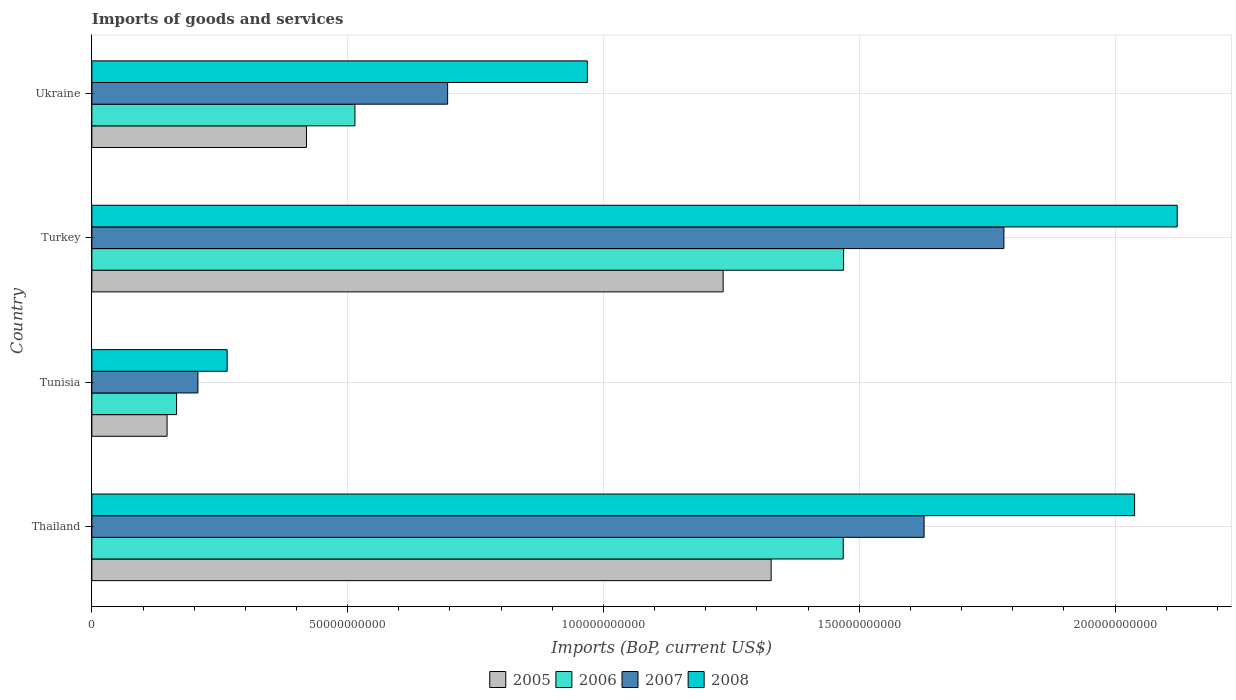Are the number of bars per tick equal to the number of legend labels?
Your answer should be very brief. Yes. What is the label of the 3rd group of bars from the top?
Make the answer very short. Tunisia. What is the amount spent on imports in 2008 in Turkey?
Offer a terse response. 2.12e+11. Across all countries, what is the maximum amount spent on imports in 2007?
Your answer should be compact. 1.78e+11. Across all countries, what is the minimum amount spent on imports in 2005?
Keep it short and to the point. 1.47e+1. In which country was the amount spent on imports in 2006 maximum?
Provide a short and direct response. Turkey. In which country was the amount spent on imports in 2005 minimum?
Provide a succinct answer. Tunisia. What is the total amount spent on imports in 2008 in the graph?
Offer a very short reply. 5.39e+11. What is the difference between the amount spent on imports in 2006 in Tunisia and that in Ukraine?
Ensure brevity in your answer.  -3.49e+1. What is the difference between the amount spent on imports in 2006 in Turkey and the amount spent on imports in 2005 in Ukraine?
Provide a short and direct response. 1.05e+11. What is the average amount spent on imports in 2007 per country?
Ensure brevity in your answer.  1.08e+11. What is the difference between the amount spent on imports in 2008 and amount spent on imports in 2007 in Thailand?
Make the answer very short. 4.11e+1. What is the ratio of the amount spent on imports in 2007 in Thailand to that in Ukraine?
Provide a succinct answer. 2.34. Is the difference between the amount spent on imports in 2008 in Thailand and Ukraine greater than the difference between the amount spent on imports in 2007 in Thailand and Ukraine?
Make the answer very short. Yes. What is the difference between the highest and the second highest amount spent on imports in 2008?
Offer a terse response. 8.33e+09. What is the difference between the highest and the lowest amount spent on imports in 2006?
Give a very brief answer. 1.30e+11. In how many countries, is the amount spent on imports in 2006 greater than the average amount spent on imports in 2006 taken over all countries?
Offer a very short reply. 2. Is the sum of the amount spent on imports in 2007 in Turkey and Ukraine greater than the maximum amount spent on imports in 2006 across all countries?
Provide a succinct answer. Yes. Is it the case that in every country, the sum of the amount spent on imports in 2008 and amount spent on imports in 2006 is greater than the amount spent on imports in 2005?
Keep it short and to the point. Yes. Are all the bars in the graph horizontal?
Make the answer very short. Yes. What is the difference between two consecutive major ticks on the X-axis?
Your answer should be compact. 5.00e+1. Are the values on the major ticks of X-axis written in scientific E-notation?
Keep it short and to the point. No. Does the graph contain grids?
Make the answer very short. Yes. What is the title of the graph?
Your answer should be compact. Imports of goods and services. What is the label or title of the X-axis?
Your answer should be very brief. Imports (BoP, current US$). What is the label or title of the Y-axis?
Ensure brevity in your answer.  Country. What is the Imports (BoP, current US$) in 2005 in Thailand?
Provide a short and direct response. 1.33e+11. What is the Imports (BoP, current US$) in 2006 in Thailand?
Your response must be concise. 1.47e+11. What is the Imports (BoP, current US$) in 2007 in Thailand?
Provide a succinct answer. 1.63e+11. What is the Imports (BoP, current US$) of 2008 in Thailand?
Offer a terse response. 2.04e+11. What is the Imports (BoP, current US$) of 2005 in Tunisia?
Your answer should be very brief. 1.47e+1. What is the Imports (BoP, current US$) in 2006 in Tunisia?
Offer a terse response. 1.66e+1. What is the Imports (BoP, current US$) of 2007 in Tunisia?
Offer a very short reply. 2.07e+1. What is the Imports (BoP, current US$) of 2008 in Tunisia?
Your answer should be compact. 2.64e+1. What is the Imports (BoP, current US$) of 2005 in Turkey?
Offer a terse response. 1.23e+11. What is the Imports (BoP, current US$) of 2006 in Turkey?
Your answer should be compact. 1.47e+11. What is the Imports (BoP, current US$) in 2007 in Turkey?
Keep it short and to the point. 1.78e+11. What is the Imports (BoP, current US$) in 2008 in Turkey?
Make the answer very short. 2.12e+11. What is the Imports (BoP, current US$) in 2005 in Ukraine?
Keep it short and to the point. 4.20e+1. What is the Imports (BoP, current US$) in 2006 in Ukraine?
Provide a succinct answer. 5.14e+1. What is the Imports (BoP, current US$) of 2007 in Ukraine?
Offer a very short reply. 6.95e+1. What is the Imports (BoP, current US$) of 2008 in Ukraine?
Give a very brief answer. 9.68e+1. Across all countries, what is the maximum Imports (BoP, current US$) in 2005?
Your answer should be compact. 1.33e+11. Across all countries, what is the maximum Imports (BoP, current US$) in 2006?
Offer a terse response. 1.47e+11. Across all countries, what is the maximum Imports (BoP, current US$) in 2007?
Your answer should be very brief. 1.78e+11. Across all countries, what is the maximum Imports (BoP, current US$) in 2008?
Your answer should be very brief. 2.12e+11. Across all countries, what is the minimum Imports (BoP, current US$) of 2005?
Provide a short and direct response. 1.47e+1. Across all countries, what is the minimum Imports (BoP, current US$) of 2006?
Your answer should be compact. 1.66e+1. Across all countries, what is the minimum Imports (BoP, current US$) of 2007?
Your answer should be very brief. 2.07e+1. Across all countries, what is the minimum Imports (BoP, current US$) of 2008?
Give a very brief answer. 2.64e+1. What is the total Imports (BoP, current US$) in 2005 in the graph?
Provide a succinct answer. 3.13e+11. What is the total Imports (BoP, current US$) of 2006 in the graph?
Your answer should be compact. 3.62e+11. What is the total Imports (BoP, current US$) in 2007 in the graph?
Provide a succinct answer. 4.31e+11. What is the total Imports (BoP, current US$) in 2008 in the graph?
Offer a very short reply. 5.39e+11. What is the difference between the Imports (BoP, current US$) of 2005 in Thailand and that in Tunisia?
Provide a succinct answer. 1.18e+11. What is the difference between the Imports (BoP, current US$) in 2006 in Thailand and that in Tunisia?
Provide a short and direct response. 1.30e+11. What is the difference between the Imports (BoP, current US$) in 2007 in Thailand and that in Tunisia?
Offer a terse response. 1.42e+11. What is the difference between the Imports (BoP, current US$) of 2008 in Thailand and that in Tunisia?
Your answer should be compact. 1.77e+11. What is the difference between the Imports (BoP, current US$) in 2005 in Thailand and that in Turkey?
Your answer should be compact. 9.38e+09. What is the difference between the Imports (BoP, current US$) in 2006 in Thailand and that in Turkey?
Your answer should be very brief. -7.10e+07. What is the difference between the Imports (BoP, current US$) in 2007 in Thailand and that in Turkey?
Give a very brief answer. -1.56e+1. What is the difference between the Imports (BoP, current US$) in 2008 in Thailand and that in Turkey?
Give a very brief answer. -8.33e+09. What is the difference between the Imports (BoP, current US$) of 2005 in Thailand and that in Ukraine?
Your response must be concise. 9.08e+1. What is the difference between the Imports (BoP, current US$) in 2006 in Thailand and that in Ukraine?
Make the answer very short. 9.54e+1. What is the difference between the Imports (BoP, current US$) of 2007 in Thailand and that in Ukraine?
Provide a short and direct response. 9.31e+1. What is the difference between the Imports (BoP, current US$) in 2008 in Thailand and that in Ukraine?
Keep it short and to the point. 1.07e+11. What is the difference between the Imports (BoP, current US$) of 2005 in Tunisia and that in Turkey?
Give a very brief answer. -1.09e+11. What is the difference between the Imports (BoP, current US$) in 2006 in Tunisia and that in Turkey?
Offer a very short reply. -1.30e+11. What is the difference between the Imports (BoP, current US$) in 2007 in Tunisia and that in Turkey?
Offer a very short reply. -1.58e+11. What is the difference between the Imports (BoP, current US$) in 2008 in Tunisia and that in Turkey?
Your answer should be compact. -1.86e+11. What is the difference between the Imports (BoP, current US$) of 2005 in Tunisia and that in Ukraine?
Give a very brief answer. -2.73e+1. What is the difference between the Imports (BoP, current US$) in 2006 in Tunisia and that in Ukraine?
Offer a terse response. -3.49e+1. What is the difference between the Imports (BoP, current US$) in 2007 in Tunisia and that in Ukraine?
Keep it short and to the point. -4.88e+1. What is the difference between the Imports (BoP, current US$) of 2008 in Tunisia and that in Ukraine?
Ensure brevity in your answer.  -7.04e+1. What is the difference between the Imports (BoP, current US$) in 2005 in Turkey and that in Ukraine?
Provide a succinct answer. 8.14e+1. What is the difference between the Imports (BoP, current US$) in 2006 in Turkey and that in Ukraine?
Offer a terse response. 9.55e+1. What is the difference between the Imports (BoP, current US$) of 2007 in Turkey and that in Ukraine?
Offer a terse response. 1.09e+11. What is the difference between the Imports (BoP, current US$) in 2008 in Turkey and that in Ukraine?
Make the answer very short. 1.15e+11. What is the difference between the Imports (BoP, current US$) of 2005 in Thailand and the Imports (BoP, current US$) of 2006 in Tunisia?
Your answer should be compact. 1.16e+11. What is the difference between the Imports (BoP, current US$) of 2005 in Thailand and the Imports (BoP, current US$) of 2007 in Tunisia?
Provide a succinct answer. 1.12e+11. What is the difference between the Imports (BoP, current US$) of 2005 in Thailand and the Imports (BoP, current US$) of 2008 in Tunisia?
Ensure brevity in your answer.  1.06e+11. What is the difference between the Imports (BoP, current US$) of 2006 in Thailand and the Imports (BoP, current US$) of 2007 in Tunisia?
Your answer should be compact. 1.26e+11. What is the difference between the Imports (BoP, current US$) of 2006 in Thailand and the Imports (BoP, current US$) of 2008 in Tunisia?
Your answer should be very brief. 1.20e+11. What is the difference between the Imports (BoP, current US$) in 2007 in Thailand and the Imports (BoP, current US$) in 2008 in Tunisia?
Give a very brief answer. 1.36e+11. What is the difference between the Imports (BoP, current US$) of 2005 in Thailand and the Imports (BoP, current US$) of 2006 in Turkey?
Ensure brevity in your answer.  -1.42e+1. What is the difference between the Imports (BoP, current US$) in 2005 in Thailand and the Imports (BoP, current US$) in 2007 in Turkey?
Provide a short and direct response. -4.55e+1. What is the difference between the Imports (BoP, current US$) of 2005 in Thailand and the Imports (BoP, current US$) of 2008 in Turkey?
Provide a succinct answer. -7.94e+1. What is the difference between the Imports (BoP, current US$) of 2006 in Thailand and the Imports (BoP, current US$) of 2007 in Turkey?
Make the answer very short. -3.14e+1. What is the difference between the Imports (BoP, current US$) of 2006 in Thailand and the Imports (BoP, current US$) of 2008 in Turkey?
Give a very brief answer. -6.53e+1. What is the difference between the Imports (BoP, current US$) of 2007 in Thailand and the Imports (BoP, current US$) of 2008 in Turkey?
Provide a short and direct response. -4.95e+1. What is the difference between the Imports (BoP, current US$) of 2005 in Thailand and the Imports (BoP, current US$) of 2006 in Ukraine?
Provide a short and direct response. 8.14e+1. What is the difference between the Imports (BoP, current US$) of 2005 in Thailand and the Imports (BoP, current US$) of 2007 in Ukraine?
Provide a short and direct response. 6.32e+1. What is the difference between the Imports (BoP, current US$) of 2005 in Thailand and the Imports (BoP, current US$) of 2008 in Ukraine?
Your answer should be very brief. 3.59e+1. What is the difference between the Imports (BoP, current US$) in 2006 in Thailand and the Imports (BoP, current US$) in 2007 in Ukraine?
Your response must be concise. 7.73e+1. What is the difference between the Imports (BoP, current US$) of 2006 in Thailand and the Imports (BoP, current US$) of 2008 in Ukraine?
Ensure brevity in your answer.  5.00e+1. What is the difference between the Imports (BoP, current US$) of 2007 in Thailand and the Imports (BoP, current US$) of 2008 in Ukraine?
Provide a succinct answer. 6.58e+1. What is the difference between the Imports (BoP, current US$) of 2005 in Tunisia and the Imports (BoP, current US$) of 2006 in Turkey?
Give a very brief answer. -1.32e+11. What is the difference between the Imports (BoP, current US$) of 2005 in Tunisia and the Imports (BoP, current US$) of 2007 in Turkey?
Provide a short and direct response. -1.64e+11. What is the difference between the Imports (BoP, current US$) of 2005 in Tunisia and the Imports (BoP, current US$) of 2008 in Turkey?
Ensure brevity in your answer.  -1.97e+11. What is the difference between the Imports (BoP, current US$) in 2006 in Tunisia and the Imports (BoP, current US$) in 2007 in Turkey?
Your response must be concise. -1.62e+11. What is the difference between the Imports (BoP, current US$) in 2006 in Tunisia and the Imports (BoP, current US$) in 2008 in Turkey?
Provide a short and direct response. -1.96e+11. What is the difference between the Imports (BoP, current US$) of 2007 in Tunisia and the Imports (BoP, current US$) of 2008 in Turkey?
Offer a terse response. -1.91e+11. What is the difference between the Imports (BoP, current US$) in 2005 in Tunisia and the Imports (BoP, current US$) in 2006 in Ukraine?
Provide a short and direct response. -3.67e+1. What is the difference between the Imports (BoP, current US$) in 2005 in Tunisia and the Imports (BoP, current US$) in 2007 in Ukraine?
Give a very brief answer. -5.48e+1. What is the difference between the Imports (BoP, current US$) of 2005 in Tunisia and the Imports (BoP, current US$) of 2008 in Ukraine?
Provide a short and direct response. -8.21e+1. What is the difference between the Imports (BoP, current US$) in 2006 in Tunisia and the Imports (BoP, current US$) in 2007 in Ukraine?
Your answer should be compact. -5.30e+1. What is the difference between the Imports (BoP, current US$) of 2006 in Tunisia and the Imports (BoP, current US$) of 2008 in Ukraine?
Provide a short and direct response. -8.03e+1. What is the difference between the Imports (BoP, current US$) in 2007 in Tunisia and the Imports (BoP, current US$) in 2008 in Ukraine?
Provide a succinct answer. -7.61e+1. What is the difference between the Imports (BoP, current US$) in 2005 in Turkey and the Imports (BoP, current US$) in 2006 in Ukraine?
Your answer should be compact. 7.20e+1. What is the difference between the Imports (BoP, current US$) of 2005 in Turkey and the Imports (BoP, current US$) of 2007 in Ukraine?
Your response must be concise. 5.39e+1. What is the difference between the Imports (BoP, current US$) of 2005 in Turkey and the Imports (BoP, current US$) of 2008 in Ukraine?
Offer a very short reply. 2.65e+1. What is the difference between the Imports (BoP, current US$) in 2006 in Turkey and the Imports (BoP, current US$) in 2007 in Ukraine?
Your response must be concise. 7.74e+1. What is the difference between the Imports (BoP, current US$) in 2006 in Turkey and the Imports (BoP, current US$) in 2008 in Ukraine?
Ensure brevity in your answer.  5.01e+1. What is the difference between the Imports (BoP, current US$) of 2007 in Turkey and the Imports (BoP, current US$) of 2008 in Ukraine?
Your answer should be very brief. 8.14e+1. What is the average Imports (BoP, current US$) of 2005 per country?
Your answer should be very brief. 7.82e+1. What is the average Imports (BoP, current US$) of 2006 per country?
Keep it short and to the point. 9.04e+1. What is the average Imports (BoP, current US$) in 2007 per country?
Your answer should be very brief. 1.08e+11. What is the average Imports (BoP, current US$) of 2008 per country?
Offer a terse response. 1.35e+11. What is the difference between the Imports (BoP, current US$) in 2005 and Imports (BoP, current US$) in 2006 in Thailand?
Your answer should be very brief. -1.41e+1. What is the difference between the Imports (BoP, current US$) of 2005 and Imports (BoP, current US$) of 2007 in Thailand?
Provide a succinct answer. -2.99e+1. What is the difference between the Imports (BoP, current US$) of 2005 and Imports (BoP, current US$) of 2008 in Thailand?
Ensure brevity in your answer.  -7.10e+1. What is the difference between the Imports (BoP, current US$) of 2006 and Imports (BoP, current US$) of 2007 in Thailand?
Offer a very short reply. -1.58e+1. What is the difference between the Imports (BoP, current US$) in 2006 and Imports (BoP, current US$) in 2008 in Thailand?
Offer a terse response. -5.70e+1. What is the difference between the Imports (BoP, current US$) in 2007 and Imports (BoP, current US$) in 2008 in Thailand?
Your answer should be compact. -4.11e+1. What is the difference between the Imports (BoP, current US$) in 2005 and Imports (BoP, current US$) in 2006 in Tunisia?
Offer a terse response. -1.86e+09. What is the difference between the Imports (BoP, current US$) in 2005 and Imports (BoP, current US$) in 2007 in Tunisia?
Your response must be concise. -6.03e+09. What is the difference between the Imports (BoP, current US$) in 2005 and Imports (BoP, current US$) in 2008 in Tunisia?
Provide a short and direct response. -1.17e+1. What is the difference between the Imports (BoP, current US$) in 2006 and Imports (BoP, current US$) in 2007 in Tunisia?
Make the answer very short. -4.17e+09. What is the difference between the Imports (BoP, current US$) in 2006 and Imports (BoP, current US$) in 2008 in Tunisia?
Ensure brevity in your answer.  -9.88e+09. What is the difference between the Imports (BoP, current US$) of 2007 and Imports (BoP, current US$) of 2008 in Tunisia?
Your answer should be compact. -5.71e+09. What is the difference between the Imports (BoP, current US$) of 2005 and Imports (BoP, current US$) of 2006 in Turkey?
Your response must be concise. -2.35e+1. What is the difference between the Imports (BoP, current US$) of 2005 and Imports (BoP, current US$) of 2007 in Turkey?
Give a very brief answer. -5.49e+1. What is the difference between the Imports (BoP, current US$) in 2005 and Imports (BoP, current US$) in 2008 in Turkey?
Offer a very short reply. -8.88e+1. What is the difference between the Imports (BoP, current US$) in 2006 and Imports (BoP, current US$) in 2007 in Turkey?
Your answer should be compact. -3.13e+1. What is the difference between the Imports (BoP, current US$) of 2006 and Imports (BoP, current US$) of 2008 in Turkey?
Keep it short and to the point. -6.52e+1. What is the difference between the Imports (BoP, current US$) in 2007 and Imports (BoP, current US$) in 2008 in Turkey?
Keep it short and to the point. -3.39e+1. What is the difference between the Imports (BoP, current US$) of 2005 and Imports (BoP, current US$) of 2006 in Ukraine?
Give a very brief answer. -9.47e+09. What is the difference between the Imports (BoP, current US$) of 2005 and Imports (BoP, current US$) of 2007 in Ukraine?
Offer a terse response. -2.76e+1. What is the difference between the Imports (BoP, current US$) in 2005 and Imports (BoP, current US$) in 2008 in Ukraine?
Offer a terse response. -5.49e+1. What is the difference between the Imports (BoP, current US$) in 2006 and Imports (BoP, current US$) in 2007 in Ukraine?
Offer a very short reply. -1.81e+1. What is the difference between the Imports (BoP, current US$) of 2006 and Imports (BoP, current US$) of 2008 in Ukraine?
Provide a short and direct response. -4.54e+1. What is the difference between the Imports (BoP, current US$) of 2007 and Imports (BoP, current US$) of 2008 in Ukraine?
Give a very brief answer. -2.73e+1. What is the ratio of the Imports (BoP, current US$) of 2005 in Thailand to that in Tunisia?
Provide a succinct answer. 9.03. What is the ratio of the Imports (BoP, current US$) in 2006 in Thailand to that in Tunisia?
Ensure brevity in your answer.  8.87. What is the ratio of the Imports (BoP, current US$) of 2007 in Thailand to that in Tunisia?
Provide a succinct answer. 7.85. What is the ratio of the Imports (BoP, current US$) in 2008 in Thailand to that in Tunisia?
Provide a succinct answer. 7.71. What is the ratio of the Imports (BoP, current US$) of 2005 in Thailand to that in Turkey?
Provide a succinct answer. 1.08. What is the ratio of the Imports (BoP, current US$) in 2007 in Thailand to that in Turkey?
Your answer should be compact. 0.91. What is the ratio of the Imports (BoP, current US$) in 2008 in Thailand to that in Turkey?
Ensure brevity in your answer.  0.96. What is the ratio of the Imports (BoP, current US$) of 2005 in Thailand to that in Ukraine?
Give a very brief answer. 3.17. What is the ratio of the Imports (BoP, current US$) in 2006 in Thailand to that in Ukraine?
Ensure brevity in your answer.  2.86. What is the ratio of the Imports (BoP, current US$) in 2007 in Thailand to that in Ukraine?
Give a very brief answer. 2.34. What is the ratio of the Imports (BoP, current US$) of 2008 in Thailand to that in Ukraine?
Keep it short and to the point. 2.1. What is the ratio of the Imports (BoP, current US$) of 2005 in Tunisia to that in Turkey?
Keep it short and to the point. 0.12. What is the ratio of the Imports (BoP, current US$) of 2006 in Tunisia to that in Turkey?
Keep it short and to the point. 0.11. What is the ratio of the Imports (BoP, current US$) in 2007 in Tunisia to that in Turkey?
Offer a very short reply. 0.12. What is the ratio of the Imports (BoP, current US$) of 2008 in Tunisia to that in Turkey?
Offer a very short reply. 0.12. What is the ratio of the Imports (BoP, current US$) of 2005 in Tunisia to that in Ukraine?
Offer a terse response. 0.35. What is the ratio of the Imports (BoP, current US$) of 2006 in Tunisia to that in Ukraine?
Provide a short and direct response. 0.32. What is the ratio of the Imports (BoP, current US$) in 2007 in Tunisia to that in Ukraine?
Give a very brief answer. 0.3. What is the ratio of the Imports (BoP, current US$) in 2008 in Tunisia to that in Ukraine?
Your answer should be compact. 0.27. What is the ratio of the Imports (BoP, current US$) of 2005 in Turkey to that in Ukraine?
Provide a short and direct response. 2.94. What is the ratio of the Imports (BoP, current US$) of 2006 in Turkey to that in Ukraine?
Your answer should be very brief. 2.86. What is the ratio of the Imports (BoP, current US$) in 2007 in Turkey to that in Ukraine?
Provide a short and direct response. 2.56. What is the ratio of the Imports (BoP, current US$) of 2008 in Turkey to that in Ukraine?
Your answer should be compact. 2.19. What is the difference between the highest and the second highest Imports (BoP, current US$) of 2005?
Offer a terse response. 9.38e+09. What is the difference between the highest and the second highest Imports (BoP, current US$) in 2006?
Offer a terse response. 7.10e+07. What is the difference between the highest and the second highest Imports (BoP, current US$) of 2007?
Give a very brief answer. 1.56e+1. What is the difference between the highest and the second highest Imports (BoP, current US$) in 2008?
Your answer should be very brief. 8.33e+09. What is the difference between the highest and the lowest Imports (BoP, current US$) of 2005?
Offer a terse response. 1.18e+11. What is the difference between the highest and the lowest Imports (BoP, current US$) of 2006?
Give a very brief answer. 1.30e+11. What is the difference between the highest and the lowest Imports (BoP, current US$) of 2007?
Keep it short and to the point. 1.58e+11. What is the difference between the highest and the lowest Imports (BoP, current US$) of 2008?
Ensure brevity in your answer.  1.86e+11. 